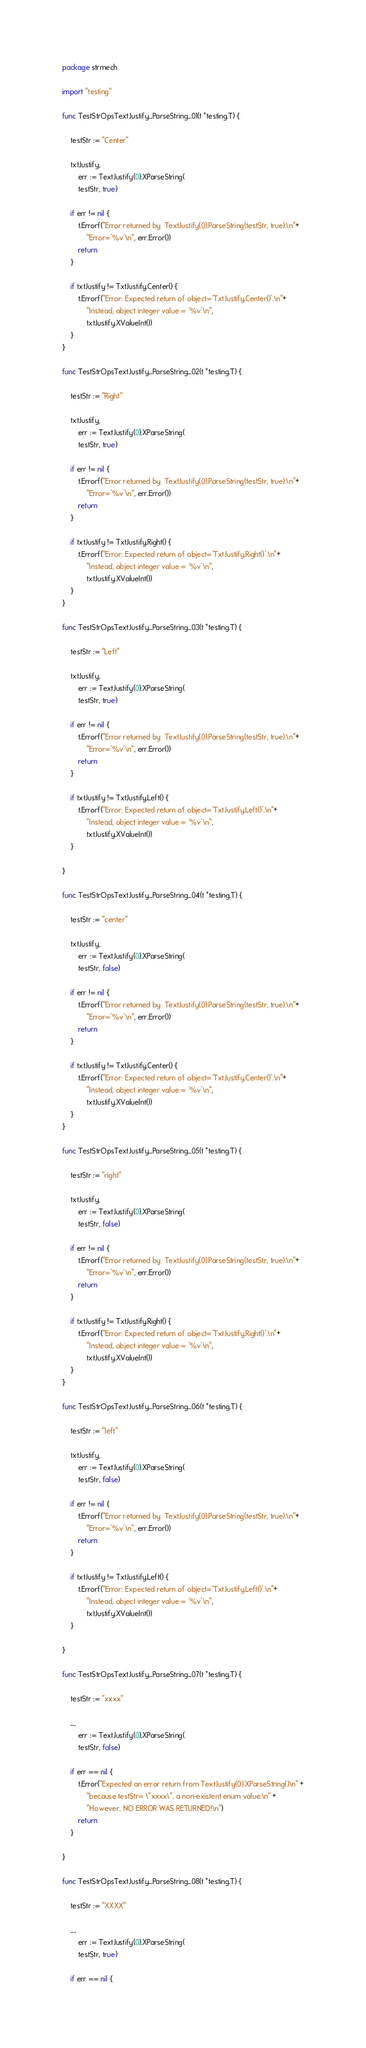<code> <loc_0><loc_0><loc_500><loc_500><_Go_>package strmech

import "testing"

func TestStrOpsTextJustify_ParseString_01(t *testing.T) {

	testStr := "Center"

	txtJustify,
		err := TextJustify(0).XParseString(
		testStr, true)

	if err != nil {
		t.Errorf("Error returned by  TextJustify(0).ParseString(testStr, true).\n"+
			"Error='%v'\n", err.Error())
		return
	}

	if txtJustify != TxtJustify.Center() {
		t.Errorf("Error: Expected return of object='TxtJustify.Center()'.\n"+
			"Instead, object integer value = '%v'\n",
			txtJustify.XValueInt())
	}
}

func TestStrOpsTextJustify_ParseString_02(t *testing.T) {

	testStr := "Right"

	txtJustify,
		err := TextJustify(0).XParseString(
		testStr, true)

	if err != nil {
		t.Errorf("Error returned by  TextJustify(0).ParseString(testStr, true).\n"+
			"Error='%v'\n", err.Error())
		return
	}

	if txtJustify != TxtJustify.Right() {
		t.Errorf("Error: Expected return of object='TxtJustify.Right()'.\n"+
			"Instead, object integer value = '%v'\n",
			txtJustify.XValueInt())
	}
}

func TestStrOpsTextJustify_ParseString_03(t *testing.T) {

	testStr := "Left"

	txtJustify,
		err := TextJustify(0).XParseString(
		testStr, true)

	if err != nil {
		t.Errorf("Error returned by  TextJustify(0).ParseString(testStr, true).\n"+
			"Error='%v'\n", err.Error())
		return
	}

	if txtJustify != TxtJustify.Left() {
		t.Errorf("Error: Expected return of object='TxtJustify.Left()'.\n"+
			"Instead, object integer value = '%v'\n",
			txtJustify.XValueInt())
	}

}

func TestStrOpsTextJustify_ParseString_04(t *testing.T) {

	testStr := "center"

	txtJustify,
		err := TextJustify(0).XParseString(
		testStr, false)

	if err != nil {
		t.Errorf("Error returned by  TextJustify(0).ParseString(testStr, true).\n"+
			"Error='%v'\n", err.Error())
		return
	}

	if txtJustify != TxtJustify.Center() {
		t.Errorf("Error: Expected return of object='TxtJustify.Center()'.\n"+
			"Instead, object integer value = '%v'\n",
			txtJustify.XValueInt())
	}
}

func TestStrOpsTextJustify_ParseString_05(t *testing.T) {

	testStr := "right"

	txtJustify,
		err := TextJustify(0).XParseString(
		testStr, false)

	if err != nil {
		t.Errorf("Error returned by  TextJustify(0).ParseString(testStr, true).\n"+
			"Error='%v'\n", err.Error())
		return
	}

	if txtJustify != TxtJustify.Right() {
		t.Errorf("Error: Expected return of object='TxtJustify.Right()'.\n"+
			"Instead, object integer value = '%v'\n",
			txtJustify.XValueInt())
	}
}

func TestStrOpsTextJustify_ParseString_06(t *testing.T) {

	testStr := "left"

	txtJustify,
		err := TextJustify(0).XParseString(
		testStr, false)

	if err != nil {
		t.Errorf("Error returned by  TextJustify(0).ParseString(testStr, true).\n"+
			"Error='%v'\n", err.Error())
		return
	}

	if txtJustify != TxtJustify.Left() {
		t.Errorf("Error: Expected return of object='TxtJustify.Left()'.\n"+
			"Instead, object integer value = '%v'\n",
			txtJustify.XValueInt())
	}

}

func TestStrOpsTextJustify_ParseString_07(t *testing.T) {

	testStr := "xxxx"

	_,
		err := TextJustify(0).XParseString(
		testStr, false)

	if err == nil {
		t.Error("Expected an error return from TextJustify(0).XParseString()\n" +
			"because testStr= \"xxxx\", a non-existent enum value.\n" +
			"However, NO ERROR WAS RETURNED!\n")
		return
	}

}

func TestStrOpsTextJustify_ParseString_08(t *testing.T) {

	testStr := "XXXX"

	_,
		err := TextJustify(0).XParseString(
		testStr, true)

	if err == nil {</code> 